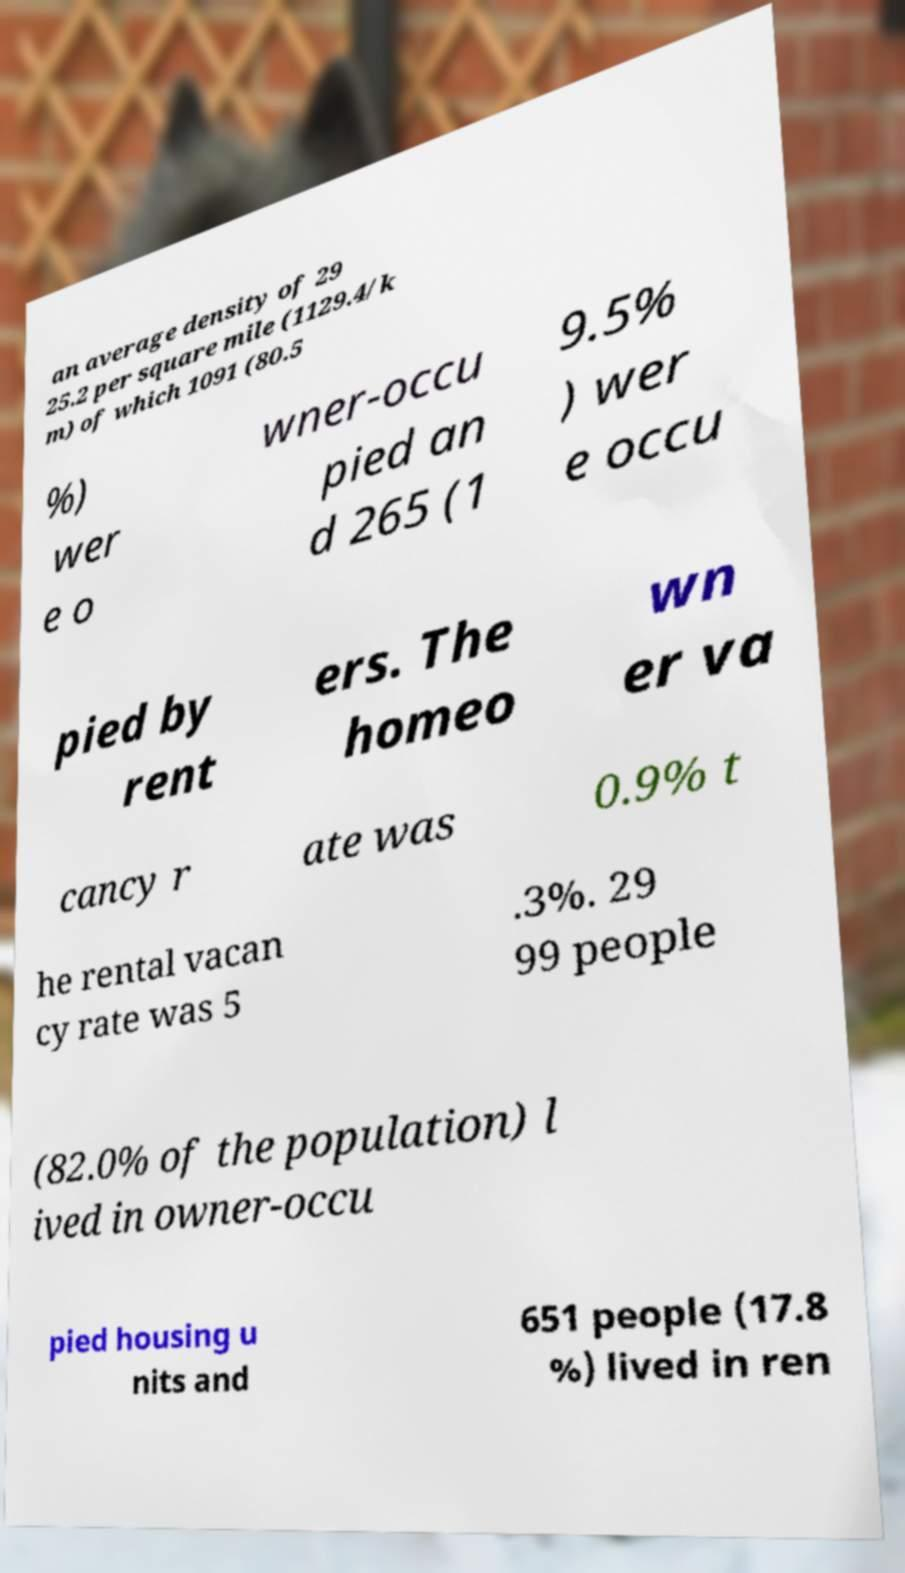There's text embedded in this image that I need extracted. Can you transcribe it verbatim? an average density of 29 25.2 per square mile (1129.4/k m) of which 1091 (80.5 %) wer e o wner-occu pied an d 265 (1 9.5% ) wer e occu pied by rent ers. The homeo wn er va cancy r ate was 0.9% t he rental vacan cy rate was 5 .3%. 29 99 people (82.0% of the population) l ived in owner-occu pied housing u nits and 651 people (17.8 %) lived in ren 